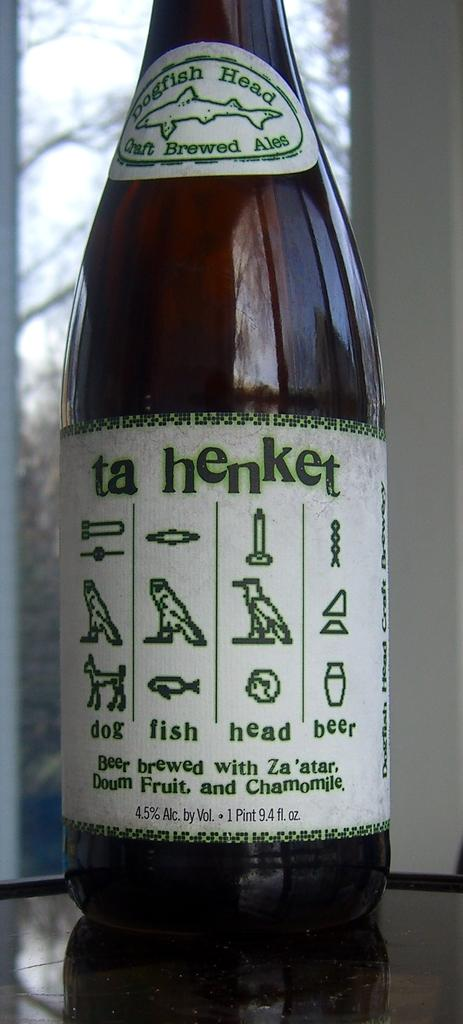<image>
Give a short and clear explanation of the subsequent image. A bottle of ta henket has a volume of 1 pint, 9.4 fl oz. 